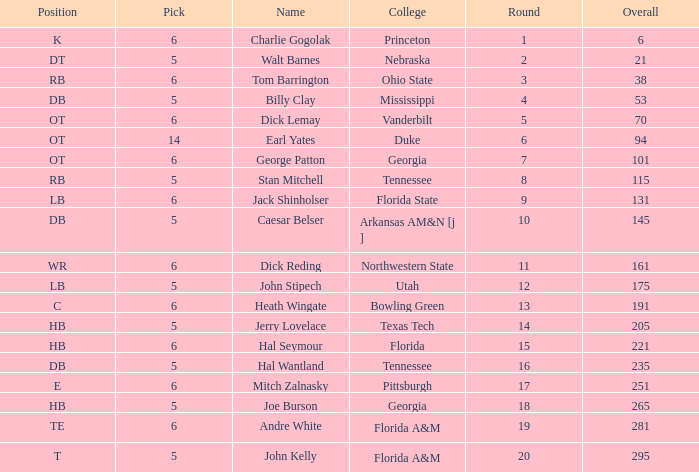What is the highest Pick, when Round is greater than 15, and when College is "Tennessee"? 5.0. 